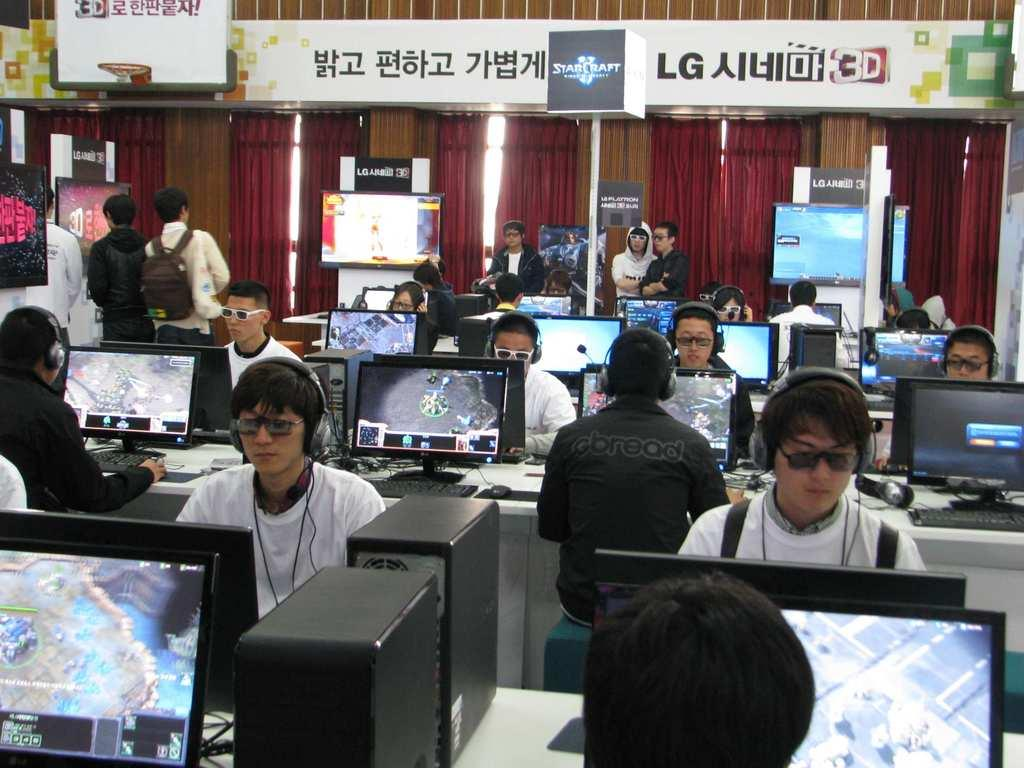What are the people in the image doing? The people in the image are sitting and operating computers. Are there any other people in the image? Yes, there are people standing at the back. What can be seen at the back of the room? There are curtains at the back. How many flocks of birds can be seen flying through the room in the image? There are no flocks of birds visible in the image; it features people sitting and operating computers, with people standing at the back and curtains at the back. 